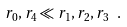<formula> <loc_0><loc_0><loc_500><loc_500>r _ { 0 } , r _ { 4 } \ll r _ { 1 } , r _ { 2 } , r _ { 3 } \ .</formula> 